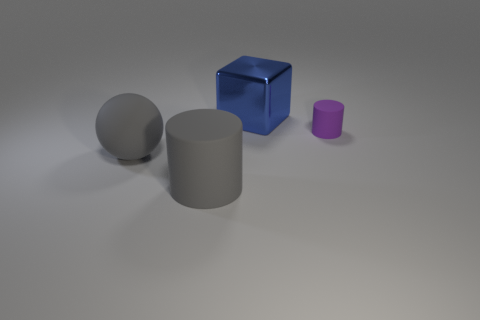Add 2 large yellow matte cylinders. How many objects exist? 6 Subtract all balls. How many objects are left? 3 Add 2 small purple rubber objects. How many small purple rubber objects exist? 3 Subtract 0 gray blocks. How many objects are left? 4 Subtract all blue cubes. Subtract all tiny purple rubber blocks. How many objects are left? 3 Add 3 big shiny cubes. How many big shiny cubes are left? 4 